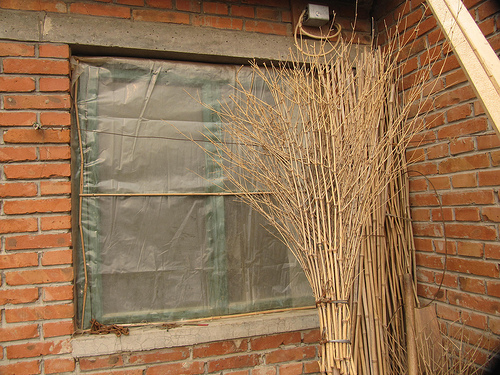<image>
Can you confirm if the window is behind the stalks? Yes. From this viewpoint, the window is positioned behind the stalks, with the stalks partially or fully occluding the window. Is there a plant in the window? No. The plant is not contained within the window. These objects have a different spatial relationship. 